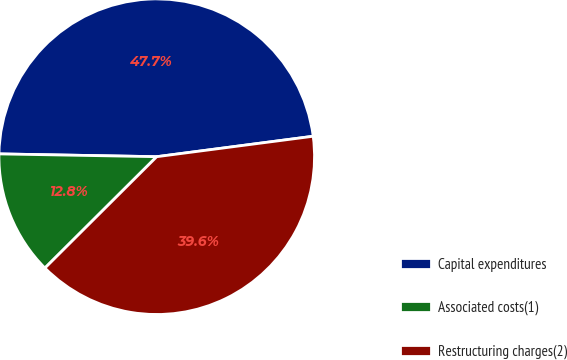Convert chart to OTSL. <chart><loc_0><loc_0><loc_500><loc_500><pie_chart><fcel>Capital expenditures<fcel>Associated costs(1)<fcel>Restructuring charges(2)<nl><fcel>47.65%<fcel>12.75%<fcel>39.6%<nl></chart> 